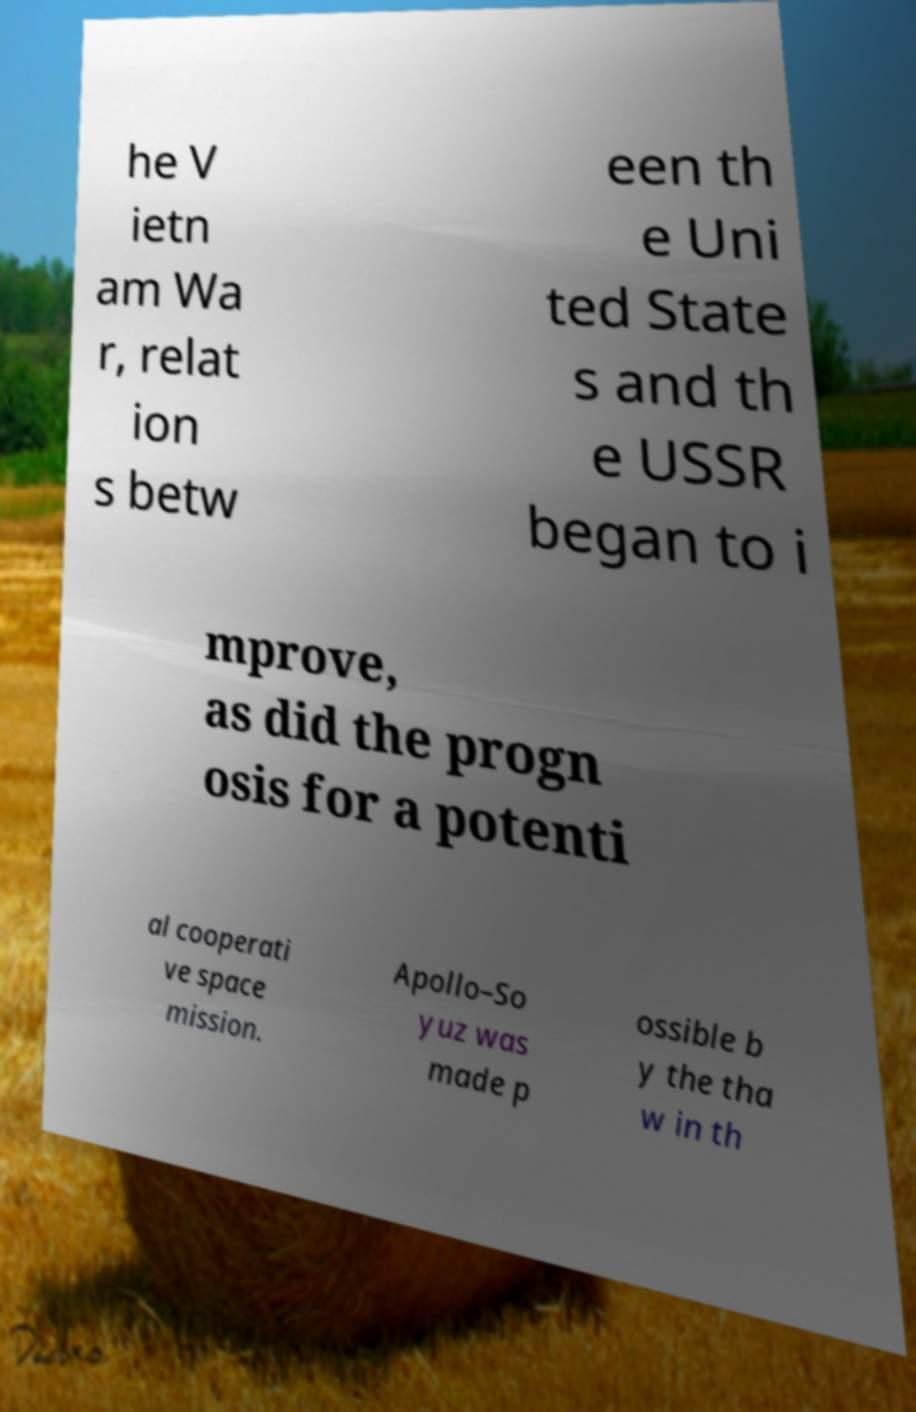What messages or text are displayed in this image? I need them in a readable, typed format. he V ietn am Wa r, relat ion s betw een th e Uni ted State s and th e USSR began to i mprove, as did the progn osis for a potenti al cooperati ve space mission. Apollo–So yuz was made p ossible b y the tha w in th 